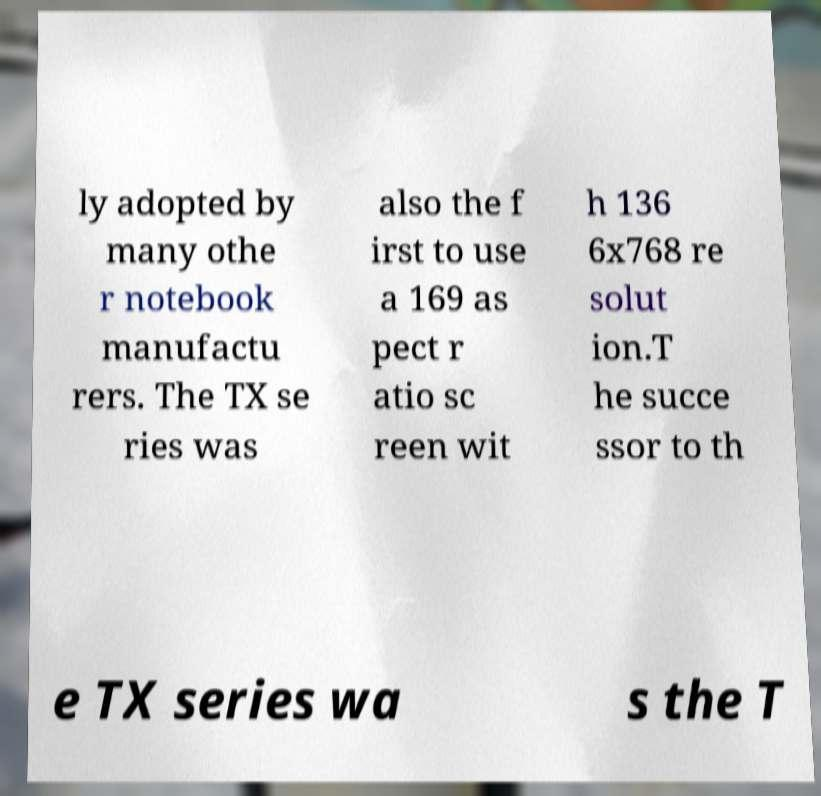Can you read and provide the text displayed in the image?This photo seems to have some interesting text. Can you extract and type it out for me? ly adopted by many othe r notebook manufactu rers. The TX se ries was also the f irst to use a 169 as pect r atio sc reen wit h 136 6x768 re solut ion.T he succe ssor to th e TX series wa s the T 